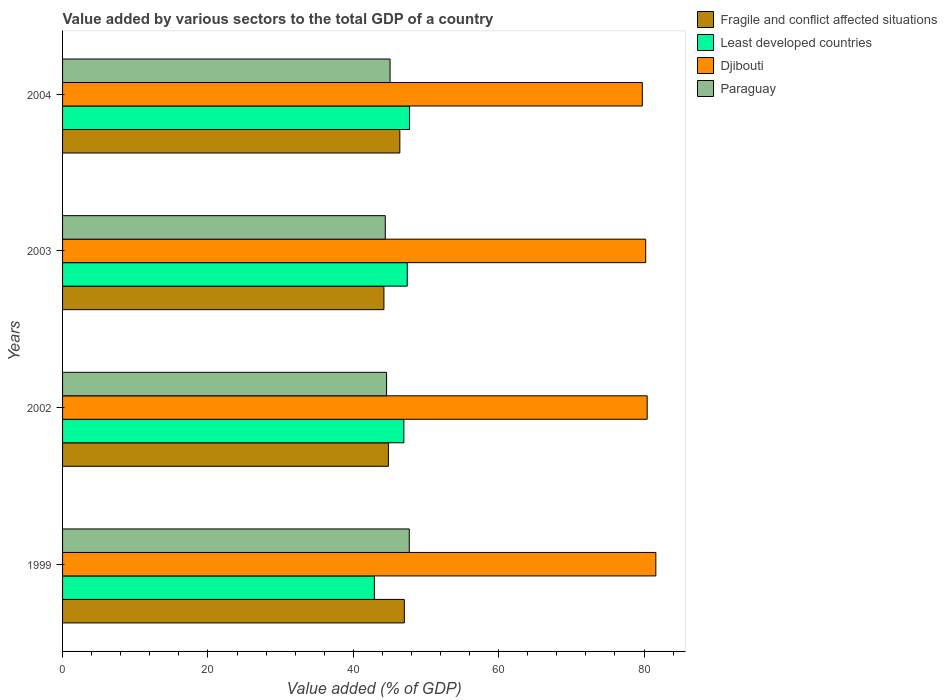How many groups of bars are there?
Give a very brief answer. 4. Are the number of bars per tick equal to the number of legend labels?
Your answer should be very brief. Yes. Are the number of bars on each tick of the Y-axis equal?
Offer a terse response. Yes. In how many cases, is the number of bars for a given year not equal to the number of legend labels?
Offer a terse response. 0. What is the value added by various sectors to the total GDP in Fragile and conflict affected situations in 1999?
Offer a terse response. 47.02. Across all years, what is the maximum value added by various sectors to the total GDP in Least developed countries?
Make the answer very short. 47.74. Across all years, what is the minimum value added by various sectors to the total GDP in Least developed countries?
Your answer should be very brief. 42.9. What is the total value added by various sectors to the total GDP in Djibouti in the graph?
Provide a short and direct response. 322.04. What is the difference between the value added by various sectors to the total GDP in Least developed countries in 1999 and that in 2002?
Your answer should be compact. -4.06. What is the difference between the value added by various sectors to the total GDP in Djibouti in 1999 and the value added by various sectors to the total GDP in Least developed countries in 2002?
Offer a terse response. 34.67. What is the average value added by various sectors to the total GDP in Djibouti per year?
Offer a very short reply. 80.51. In the year 2002, what is the difference between the value added by various sectors to the total GDP in Paraguay and value added by various sectors to the total GDP in Least developed countries?
Keep it short and to the point. -2.38. In how many years, is the value added by various sectors to the total GDP in Paraguay greater than 76 %?
Provide a succinct answer. 0. What is the ratio of the value added by various sectors to the total GDP in Fragile and conflict affected situations in 1999 to that in 2002?
Make the answer very short. 1.05. Is the difference between the value added by various sectors to the total GDP in Paraguay in 2002 and 2003 greater than the difference between the value added by various sectors to the total GDP in Least developed countries in 2002 and 2003?
Keep it short and to the point. Yes. What is the difference between the highest and the second highest value added by various sectors to the total GDP in Paraguay?
Ensure brevity in your answer.  2.65. What is the difference between the highest and the lowest value added by various sectors to the total GDP in Djibouti?
Make the answer very short. 1.86. Is it the case that in every year, the sum of the value added by various sectors to the total GDP in Least developed countries and value added by various sectors to the total GDP in Djibouti is greater than the sum of value added by various sectors to the total GDP in Paraguay and value added by various sectors to the total GDP in Fragile and conflict affected situations?
Ensure brevity in your answer.  Yes. What does the 4th bar from the top in 1999 represents?
Provide a succinct answer. Fragile and conflict affected situations. What does the 1st bar from the bottom in 2004 represents?
Offer a terse response. Fragile and conflict affected situations. Is it the case that in every year, the sum of the value added by various sectors to the total GDP in Fragile and conflict affected situations and value added by various sectors to the total GDP in Djibouti is greater than the value added by various sectors to the total GDP in Least developed countries?
Your response must be concise. Yes. How many bars are there?
Offer a terse response. 16. Are all the bars in the graph horizontal?
Provide a succinct answer. Yes. Are the values on the major ticks of X-axis written in scientific E-notation?
Offer a terse response. No. How many legend labels are there?
Give a very brief answer. 4. What is the title of the graph?
Your answer should be compact. Value added by various sectors to the total GDP of a country. What is the label or title of the X-axis?
Offer a terse response. Value added (% of GDP). What is the Value added (% of GDP) of Fragile and conflict affected situations in 1999?
Keep it short and to the point. 47.02. What is the Value added (% of GDP) of Least developed countries in 1999?
Your answer should be compact. 42.9. What is the Value added (% of GDP) in Djibouti in 1999?
Provide a short and direct response. 81.62. What is the Value added (% of GDP) of Paraguay in 1999?
Give a very brief answer. 47.7. What is the Value added (% of GDP) in Fragile and conflict affected situations in 2002?
Ensure brevity in your answer.  44.82. What is the Value added (% of GDP) in Least developed countries in 2002?
Ensure brevity in your answer.  46.95. What is the Value added (% of GDP) of Djibouti in 2002?
Make the answer very short. 80.43. What is the Value added (% of GDP) of Paraguay in 2002?
Ensure brevity in your answer.  44.58. What is the Value added (% of GDP) in Fragile and conflict affected situations in 2003?
Ensure brevity in your answer.  44.21. What is the Value added (% of GDP) of Least developed countries in 2003?
Give a very brief answer. 47.42. What is the Value added (% of GDP) in Djibouti in 2003?
Ensure brevity in your answer.  80.23. What is the Value added (% of GDP) of Paraguay in 2003?
Make the answer very short. 44.4. What is the Value added (% of GDP) in Fragile and conflict affected situations in 2004?
Make the answer very short. 46.4. What is the Value added (% of GDP) of Least developed countries in 2004?
Your response must be concise. 47.74. What is the Value added (% of GDP) in Djibouti in 2004?
Your response must be concise. 79.76. What is the Value added (% of GDP) of Paraguay in 2004?
Your answer should be very brief. 45.06. Across all years, what is the maximum Value added (% of GDP) in Fragile and conflict affected situations?
Provide a succinct answer. 47.02. Across all years, what is the maximum Value added (% of GDP) of Least developed countries?
Provide a short and direct response. 47.74. Across all years, what is the maximum Value added (% of GDP) of Djibouti?
Offer a very short reply. 81.62. Across all years, what is the maximum Value added (% of GDP) of Paraguay?
Offer a very short reply. 47.7. Across all years, what is the minimum Value added (% of GDP) of Fragile and conflict affected situations?
Provide a succinct answer. 44.21. Across all years, what is the minimum Value added (% of GDP) in Least developed countries?
Your answer should be very brief. 42.9. Across all years, what is the minimum Value added (% of GDP) of Djibouti?
Offer a very short reply. 79.76. Across all years, what is the minimum Value added (% of GDP) in Paraguay?
Your answer should be very brief. 44.4. What is the total Value added (% of GDP) of Fragile and conflict affected situations in the graph?
Offer a terse response. 182.46. What is the total Value added (% of GDP) of Least developed countries in the graph?
Your response must be concise. 185.01. What is the total Value added (% of GDP) of Djibouti in the graph?
Your answer should be compact. 322.04. What is the total Value added (% of GDP) in Paraguay in the graph?
Your answer should be compact. 181.73. What is the difference between the Value added (% of GDP) in Fragile and conflict affected situations in 1999 and that in 2002?
Your response must be concise. 2.19. What is the difference between the Value added (% of GDP) in Least developed countries in 1999 and that in 2002?
Give a very brief answer. -4.06. What is the difference between the Value added (% of GDP) in Djibouti in 1999 and that in 2002?
Provide a succinct answer. 1.19. What is the difference between the Value added (% of GDP) of Paraguay in 1999 and that in 2002?
Provide a short and direct response. 3.13. What is the difference between the Value added (% of GDP) of Fragile and conflict affected situations in 1999 and that in 2003?
Keep it short and to the point. 2.81. What is the difference between the Value added (% of GDP) of Least developed countries in 1999 and that in 2003?
Your response must be concise. -4.53. What is the difference between the Value added (% of GDP) of Djibouti in 1999 and that in 2003?
Give a very brief answer. 1.39. What is the difference between the Value added (% of GDP) of Fragile and conflict affected situations in 1999 and that in 2004?
Your answer should be compact. 0.62. What is the difference between the Value added (% of GDP) in Least developed countries in 1999 and that in 2004?
Ensure brevity in your answer.  -4.84. What is the difference between the Value added (% of GDP) of Djibouti in 1999 and that in 2004?
Ensure brevity in your answer.  1.86. What is the difference between the Value added (% of GDP) in Paraguay in 1999 and that in 2004?
Keep it short and to the point. 2.65. What is the difference between the Value added (% of GDP) of Fragile and conflict affected situations in 2002 and that in 2003?
Offer a terse response. 0.61. What is the difference between the Value added (% of GDP) in Least developed countries in 2002 and that in 2003?
Ensure brevity in your answer.  -0.47. What is the difference between the Value added (% of GDP) in Djibouti in 2002 and that in 2003?
Make the answer very short. 0.2. What is the difference between the Value added (% of GDP) of Paraguay in 2002 and that in 2003?
Your response must be concise. 0.17. What is the difference between the Value added (% of GDP) of Fragile and conflict affected situations in 2002 and that in 2004?
Your answer should be compact. -1.58. What is the difference between the Value added (% of GDP) in Least developed countries in 2002 and that in 2004?
Make the answer very short. -0.78. What is the difference between the Value added (% of GDP) in Djibouti in 2002 and that in 2004?
Give a very brief answer. 0.67. What is the difference between the Value added (% of GDP) of Paraguay in 2002 and that in 2004?
Give a very brief answer. -0.48. What is the difference between the Value added (% of GDP) in Fragile and conflict affected situations in 2003 and that in 2004?
Make the answer very short. -2.19. What is the difference between the Value added (% of GDP) in Least developed countries in 2003 and that in 2004?
Keep it short and to the point. -0.32. What is the difference between the Value added (% of GDP) of Djibouti in 2003 and that in 2004?
Give a very brief answer. 0.47. What is the difference between the Value added (% of GDP) in Paraguay in 2003 and that in 2004?
Provide a short and direct response. -0.65. What is the difference between the Value added (% of GDP) of Fragile and conflict affected situations in 1999 and the Value added (% of GDP) of Least developed countries in 2002?
Keep it short and to the point. 0.06. What is the difference between the Value added (% of GDP) of Fragile and conflict affected situations in 1999 and the Value added (% of GDP) of Djibouti in 2002?
Provide a succinct answer. -33.41. What is the difference between the Value added (% of GDP) in Fragile and conflict affected situations in 1999 and the Value added (% of GDP) in Paraguay in 2002?
Keep it short and to the point. 2.44. What is the difference between the Value added (% of GDP) of Least developed countries in 1999 and the Value added (% of GDP) of Djibouti in 2002?
Keep it short and to the point. -37.53. What is the difference between the Value added (% of GDP) of Least developed countries in 1999 and the Value added (% of GDP) of Paraguay in 2002?
Make the answer very short. -1.68. What is the difference between the Value added (% of GDP) of Djibouti in 1999 and the Value added (% of GDP) of Paraguay in 2002?
Your response must be concise. 37.05. What is the difference between the Value added (% of GDP) in Fragile and conflict affected situations in 1999 and the Value added (% of GDP) in Least developed countries in 2003?
Provide a succinct answer. -0.4. What is the difference between the Value added (% of GDP) of Fragile and conflict affected situations in 1999 and the Value added (% of GDP) of Djibouti in 2003?
Give a very brief answer. -33.21. What is the difference between the Value added (% of GDP) of Fragile and conflict affected situations in 1999 and the Value added (% of GDP) of Paraguay in 2003?
Your response must be concise. 2.62. What is the difference between the Value added (% of GDP) in Least developed countries in 1999 and the Value added (% of GDP) in Djibouti in 2003?
Keep it short and to the point. -37.33. What is the difference between the Value added (% of GDP) of Least developed countries in 1999 and the Value added (% of GDP) of Paraguay in 2003?
Make the answer very short. -1.5. What is the difference between the Value added (% of GDP) of Djibouti in 1999 and the Value added (% of GDP) of Paraguay in 2003?
Your answer should be compact. 37.22. What is the difference between the Value added (% of GDP) of Fragile and conflict affected situations in 1999 and the Value added (% of GDP) of Least developed countries in 2004?
Your answer should be compact. -0.72. What is the difference between the Value added (% of GDP) of Fragile and conflict affected situations in 1999 and the Value added (% of GDP) of Djibouti in 2004?
Keep it short and to the point. -32.74. What is the difference between the Value added (% of GDP) of Fragile and conflict affected situations in 1999 and the Value added (% of GDP) of Paraguay in 2004?
Keep it short and to the point. 1.96. What is the difference between the Value added (% of GDP) in Least developed countries in 1999 and the Value added (% of GDP) in Djibouti in 2004?
Provide a succinct answer. -36.86. What is the difference between the Value added (% of GDP) in Least developed countries in 1999 and the Value added (% of GDP) in Paraguay in 2004?
Your answer should be compact. -2.16. What is the difference between the Value added (% of GDP) in Djibouti in 1999 and the Value added (% of GDP) in Paraguay in 2004?
Offer a terse response. 36.57. What is the difference between the Value added (% of GDP) of Fragile and conflict affected situations in 2002 and the Value added (% of GDP) of Least developed countries in 2003?
Provide a succinct answer. -2.6. What is the difference between the Value added (% of GDP) of Fragile and conflict affected situations in 2002 and the Value added (% of GDP) of Djibouti in 2003?
Keep it short and to the point. -35.4. What is the difference between the Value added (% of GDP) in Fragile and conflict affected situations in 2002 and the Value added (% of GDP) in Paraguay in 2003?
Your answer should be very brief. 0.42. What is the difference between the Value added (% of GDP) in Least developed countries in 2002 and the Value added (% of GDP) in Djibouti in 2003?
Provide a short and direct response. -33.27. What is the difference between the Value added (% of GDP) of Least developed countries in 2002 and the Value added (% of GDP) of Paraguay in 2003?
Your answer should be very brief. 2.55. What is the difference between the Value added (% of GDP) in Djibouti in 2002 and the Value added (% of GDP) in Paraguay in 2003?
Your answer should be very brief. 36.03. What is the difference between the Value added (% of GDP) of Fragile and conflict affected situations in 2002 and the Value added (% of GDP) of Least developed countries in 2004?
Give a very brief answer. -2.91. What is the difference between the Value added (% of GDP) of Fragile and conflict affected situations in 2002 and the Value added (% of GDP) of Djibouti in 2004?
Your answer should be very brief. -34.93. What is the difference between the Value added (% of GDP) of Fragile and conflict affected situations in 2002 and the Value added (% of GDP) of Paraguay in 2004?
Keep it short and to the point. -0.23. What is the difference between the Value added (% of GDP) of Least developed countries in 2002 and the Value added (% of GDP) of Djibouti in 2004?
Your answer should be very brief. -32.8. What is the difference between the Value added (% of GDP) in Least developed countries in 2002 and the Value added (% of GDP) in Paraguay in 2004?
Offer a very short reply. 1.9. What is the difference between the Value added (% of GDP) of Djibouti in 2002 and the Value added (% of GDP) of Paraguay in 2004?
Your response must be concise. 35.37. What is the difference between the Value added (% of GDP) in Fragile and conflict affected situations in 2003 and the Value added (% of GDP) in Least developed countries in 2004?
Your response must be concise. -3.53. What is the difference between the Value added (% of GDP) of Fragile and conflict affected situations in 2003 and the Value added (% of GDP) of Djibouti in 2004?
Provide a succinct answer. -35.55. What is the difference between the Value added (% of GDP) in Fragile and conflict affected situations in 2003 and the Value added (% of GDP) in Paraguay in 2004?
Offer a very short reply. -0.84. What is the difference between the Value added (% of GDP) in Least developed countries in 2003 and the Value added (% of GDP) in Djibouti in 2004?
Make the answer very short. -32.34. What is the difference between the Value added (% of GDP) in Least developed countries in 2003 and the Value added (% of GDP) in Paraguay in 2004?
Your answer should be very brief. 2.37. What is the difference between the Value added (% of GDP) of Djibouti in 2003 and the Value added (% of GDP) of Paraguay in 2004?
Provide a short and direct response. 35.17. What is the average Value added (% of GDP) of Fragile and conflict affected situations per year?
Ensure brevity in your answer.  45.61. What is the average Value added (% of GDP) of Least developed countries per year?
Offer a terse response. 46.25. What is the average Value added (% of GDP) in Djibouti per year?
Provide a succinct answer. 80.51. What is the average Value added (% of GDP) of Paraguay per year?
Make the answer very short. 45.43. In the year 1999, what is the difference between the Value added (% of GDP) of Fragile and conflict affected situations and Value added (% of GDP) of Least developed countries?
Make the answer very short. 4.12. In the year 1999, what is the difference between the Value added (% of GDP) of Fragile and conflict affected situations and Value added (% of GDP) of Djibouti?
Provide a succinct answer. -34.6. In the year 1999, what is the difference between the Value added (% of GDP) of Fragile and conflict affected situations and Value added (% of GDP) of Paraguay?
Keep it short and to the point. -0.68. In the year 1999, what is the difference between the Value added (% of GDP) in Least developed countries and Value added (% of GDP) in Djibouti?
Keep it short and to the point. -38.72. In the year 1999, what is the difference between the Value added (% of GDP) in Least developed countries and Value added (% of GDP) in Paraguay?
Offer a terse response. -4.8. In the year 1999, what is the difference between the Value added (% of GDP) of Djibouti and Value added (% of GDP) of Paraguay?
Give a very brief answer. 33.92. In the year 2002, what is the difference between the Value added (% of GDP) of Fragile and conflict affected situations and Value added (% of GDP) of Least developed countries?
Offer a terse response. -2.13. In the year 2002, what is the difference between the Value added (% of GDP) in Fragile and conflict affected situations and Value added (% of GDP) in Djibouti?
Provide a short and direct response. -35.6. In the year 2002, what is the difference between the Value added (% of GDP) in Fragile and conflict affected situations and Value added (% of GDP) in Paraguay?
Offer a very short reply. 0.25. In the year 2002, what is the difference between the Value added (% of GDP) in Least developed countries and Value added (% of GDP) in Djibouti?
Offer a very short reply. -33.47. In the year 2002, what is the difference between the Value added (% of GDP) of Least developed countries and Value added (% of GDP) of Paraguay?
Provide a short and direct response. 2.38. In the year 2002, what is the difference between the Value added (% of GDP) of Djibouti and Value added (% of GDP) of Paraguay?
Offer a terse response. 35.85. In the year 2003, what is the difference between the Value added (% of GDP) of Fragile and conflict affected situations and Value added (% of GDP) of Least developed countries?
Provide a succinct answer. -3.21. In the year 2003, what is the difference between the Value added (% of GDP) in Fragile and conflict affected situations and Value added (% of GDP) in Djibouti?
Offer a very short reply. -36.01. In the year 2003, what is the difference between the Value added (% of GDP) in Fragile and conflict affected situations and Value added (% of GDP) in Paraguay?
Offer a very short reply. -0.19. In the year 2003, what is the difference between the Value added (% of GDP) of Least developed countries and Value added (% of GDP) of Djibouti?
Provide a short and direct response. -32.8. In the year 2003, what is the difference between the Value added (% of GDP) of Least developed countries and Value added (% of GDP) of Paraguay?
Your answer should be compact. 3.02. In the year 2003, what is the difference between the Value added (% of GDP) in Djibouti and Value added (% of GDP) in Paraguay?
Offer a terse response. 35.83. In the year 2004, what is the difference between the Value added (% of GDP) of Fragile and conflict affected situations and Value added (% of GDP) of Least developed countries?
Ensure brevity in your answer.  -1.34. In the year 2004, what is the difference between the Value added (% of GDP) in Fragile and conflict affected situations and Value added (% of GDP) in Djibouti?
Your answer should be compact. -33.36. In the year 2004, what is the difference between the Value added (% of GDP) of Fragile and conflict affected situations and Value added (% of GDP) of Paraguay?
Your answer should be compact. 1.35. In the year 2004, what is the difference between the Value added (% of GDP) of Least developed countries and Value added (% of GDP) of Djibouti?
Your answer should be compact. -32.02. In the year 2004, what is the difference between the Value added (% of GDP) of Least developed countries and Value added (% of GDP) of Paraguay?
Give a very brief answer. 2.68. In the year 2004, what is the difference between the Value added (% of GDP) in Djibouti and Value added (% of GDP) in Paraguay?
Make the answer very short. 34.7. What is the ratio of the Value added (% of GDP) in Fragile and conflict affected situations in 1999 to that in 2002?
Make the answer very short. 1.05. What is the ratio of the Value added (% of GDP) in Least developed countries in 1999 to that in 2002?
Offer a very short reply. 0.91. What is the ratio of the Value added (% of GDP) in Djibouti in 1999 to that in 2002?
Your answer should be very brief. 1.01. What is the ratio of the Value added (% of GDP) in Paraguay in 1999 to that in 2002?
Offer a terse response. 1.07. What is the ratio of the Value added (% of GDP) in Fragile and conflict affected situations in 1999 to that in 2003?
Make the answer very short. 1.06. What is the ratio of the Value added (% of GDP) of Least developed countries in 1999 to that in 2003?
Offer a terse response. 0.9. What is the ratio of the Value added (% of GDP) in Djibouti in 1999 to that in 2003?
Ensure brevity in your answer.  1.02. What is the ratio of the Value added (% of GDP) of Paraguay in 1999 to that in 2003?
Your response must be concise. 1.07. What is the ratio of the Value added (% of GDP) in Fragile and conflict affected situations in 1999 to that in 2004?
Offer a very short reply. 1.01. What is the ratio of the Value added (% of GDP) of Least developed countries in 1999 to that in 2004?
Offer a very short reply. 0.9. What is the ratio of the Value added (% of GDP) in Djibouti in 1999 to that in 2004?
Keep it short and to the point. 1.02. What is the ratio of the Value added (% of GDP) in Paraguay in 1999 to that in 2004?
Provide a short and direct response. 1.06. What is the ratio of the Value added (% of GDP) in Fragile and conflict affected situations in 2002 to that in 2003?
Your response must be concise. 1.01. What is the ratio of the Value added (% of GDP) in Least developed countries in 2002 to that in 2003?
Give a very brief answer. 0.99. What is the ratio of the Value added (% of GDP) of Djibouti in 2002 to that in 2003?
Keep it short and to the point. 1. What is the ratio of the Value added (% of GDP) in Least developed countries in 2002 to that in 2004?
Provide a succinct answer. 0.98. What is the ratio of the Value added (% of GDP) of Djibouti in 2002 to that in 2004?
Ensure brevity in your answer.  1.01. What is the ratio of the Value added (% of GDP) in Fragile and conflict affected situations in 2003 to that in 2004?
Offer a very short reply. 0.95. What is the ratio of the Value added (% of GDP) of Djibouti in 2003 to that in 2004?
Give a very brief answer. 1.01. What is the ratio of the Value added (% of GDP) in Paraguay in 2003 to that in 2004?
Provide a succinct answer. 0.99. What is the difference between the highest and the second highest Value added (% of GDP) in Fragile and conflict affected situations?
Your answer should be very brief. 0.62. What is the difference between the highest and the second highest Value added (% of GDP) in Least developed countries?
Give a very brief answer. 0.32. What is the difference between the highest and the second highest Value added (% of GDP) in Djibouti?
Your answer should be very brief. 1.19. What is the difference between the highest and the second highest Value added (% of GDP) in Paraguay?
Ensure brevity in your answer.  2.65. What is the difference between the highest and the lowest Value added (% of GDP) of Fragile and conflict affected situations?
Ensure brevity in your answer.  2.81. What is the difference between the highest and the lowest Value added (% of GDP) in Least developed countries?
Your answer should be very brief. 4.84. What is the difference between the highest and the lowest Value added (% of GDP) of Djibouti?
Give a very brief answer. 1.86. 